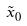Convert formula to latex. <formula><loc_0><loc_0><loc_500><loc_500>\tilde { x } _ { 0 }</formula> 